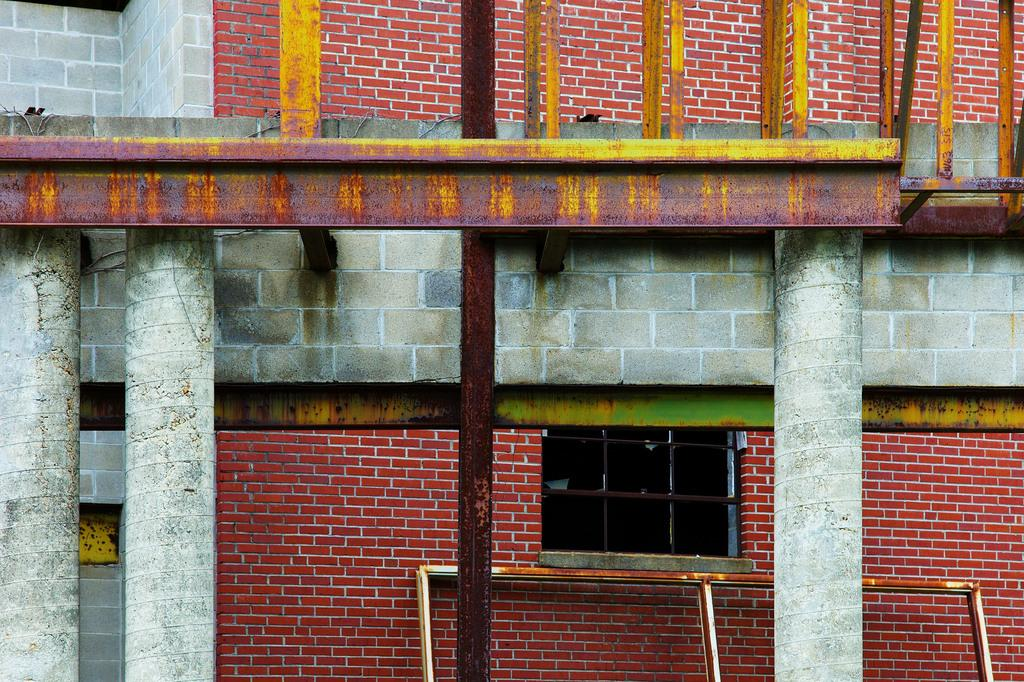What type of structure is visible in the image? There is a building in the image. Where are the pillows located in the image? The pillows are near a brick wall on the left side of the image. What material is used for the frame at the bottom of the image? The frame at the bottom of the image is made of steel. What other architectural features are present near the steel frame? The steel frame is kept near a window and pillar. What type of chairs are used for digestion in the image? There are no chairs or references to digestion present in the image. 